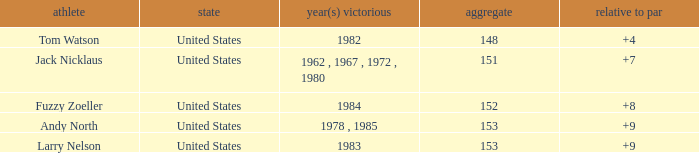What is the Total of the Player with a Year(s) won of 1982? 148.0. 